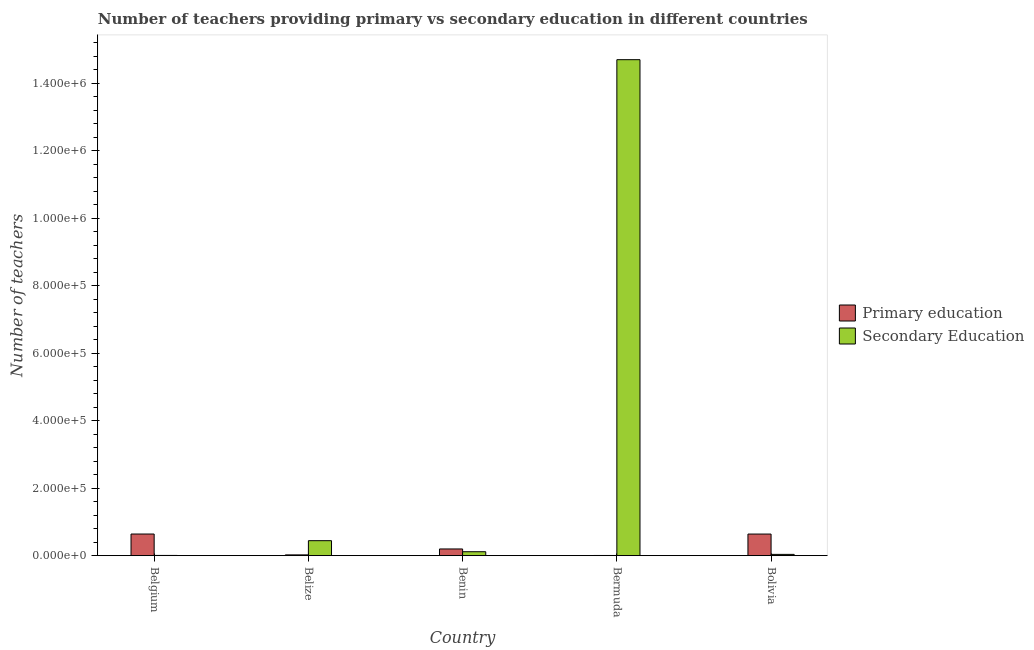How many different coloured bars are there?
Your response must be concise. 2. Are the number of bars per tick equal to the number of legend labels?
Ensure brevity in your answer.  Yes. Are the number of bars on each tick of the X-axis equal?
Give a very brief answer. Yes. How many bars are there on the 1st tick from the left?
Give a very brief answer. 2. How many bars are there on the 3rd tick from the right?
Provide a succinct answer. 2. What is the number of secondary teachers in Bermuda?
Your answer should be very brief. 1.47e+06. Across all countries, what is the maximum number of primary teachers?
Provide a succinct answer. 6.41e+04. Across all countries, what is the minimum number of secondary teachers?
Your response must be concise. 687. In which country was the number of secondary teachers maximum?
Offer a terse response. Bermuda. What is the total number of primary teachers in the graph?
Make the answer very short. 1.51e+05. What is the difference between the number of primary teachers in Benin and that in Bolivia?
Provide a succinct answer. -4.42e+04. What is the difference between the number of secondary teachers in Bermuda and the number of primary teachers in Bolivia?
Ensure brevity in your answer.  1.41e+06. What is the average number of secondary teachers per country?
Your response must be concise. 3.06e+05. What is the difference between the number of primary teachers and number of secondary teachers in Bolivia?
Your response must be concise. 6.03e+04. In how many countries, is the number of primary teachers greater than 440000 ?
Make the answer very short. 0. What is the ratio of the number of secondary teachers in Belgium to that in Bermuda?
Your answer should be compact. 0. Is the difference between the number of primary teachers in Belgium and Benin greater than the difference between the number of secondary teachers in Belgium and Benin?
Your response must be concise. Yes. What is the difference between the highest and the second highest number of secondary teachers?
Your answer should be compact. 1.43e+06. What is the difference between the highest and the lowest number of secondary teachers?
Your answer should be compact. 1.47e+06. Is the sum of the number of primary teachers in Belize and Bolivia greater than the maximum number of secondary teachers across all countries?
Provide a succinct answer. No. What does the 2nd bar from the right in Bermuda represents?
Ensure brevity in your answer.  Primary education. How many bars are there?
Offer a terse response. 10. Does the graph contain any zero values?
Your answer should be very brief. No. How many legend labels are there?
Provide a short and direct response. 2. What is the title of the graph?
Give a very brief answer. Number of teachers providing primary vs secondary education in different countries. Does "IMF concessional" appear as one of the legend labels in the graph?
Make the answer very short. No. What is the label or title of the X-axis?
Give a very brief answer. Country. What is the label or title of the Y-axis?
Provide a short and direct response. Number of teachers. What is the Number of teachers in Primary education in Belgium?
Provide a succinct answer. 6.41e+04. What is the Number of teachers of Secondary Education in Belgium?
Provide a succinct answer. 687. What is the Number of teachers in Primary education in Belize?
Provide a succinct answer. 2274. What is the Number of teachers in Secondary Education in Belize?
Keep it short and to the point. 4.44e+04. What is the Number of teachers in Primary education in Benin?
Give a very brief answer. 1.98e+04. What is the Number of teachers of Secondary Education in Benin?
Offer a terse response. 1.16e+04. What is the Number of teachers of Primary education in Bermuda?
Your response must be concise. 548. What is the Number of teachers in Secondary Education in Bermuda?
Offer a terse response. 1.47e+06. What is the Number of teachers in Primary education in Bolivia?
Provide a short and direct response. 6.40e+04. What is the Number of teachers of Secondary Education in Bolivia?
Your response must be concise. 3765. Across all countries, what is the maximum Number of teachers in Primary education?
Your response must be concise. 6.41e+04. Across all countries, what is the maximum Number of teachers of Secondary Education?
Give a very brief answer. 1.47e+06. Across all countries, what is the minimum Number of teachers of Primary education?
Your answer should be compact. 548. Across all countries, what is the minimum Number of teachers of Secondary Education?
Give a very brief answer. 687. What is the total Number of teachers of Primary education in the graph?
Keep it short and to the point. 1.51e+05. What is the total Number of teachers in Secondary Education in the graph?
Your answer should be compact. 1.53e+06. What is the difference between the Number of teachers of Primary education in Belgium and that in Belize?
Your answer should be compact. 6.19e+04. What is the difference between the Number of teachers of Secondary Education in Belgium and that in Belize?
Keep it short and to the point. -4.37e+04. What is the difference between the Number of teachers of Primary education in Belgium and that in Benin?
Your response must be concise. 4.43e+04. What is the difference between the Number of teachers in Secondary Education in Belgium and that in Benin?
Your answer should be very brief. -1.10e+04. What is the difference between the Number of teachers in Primary education in Belgium and that in Bermuda?
Give a very brief answer. 6.36e+04. What is the difference between the Number of teachers of Secondary Education in Belgium and that in Bermuda?
Provide a short and direct response. -1.47e+06. What is the difference between the Number of teachers of Secondary Education in Belgium and that in Bolivia?
Offer a very short reply. -3078. What is the difference between the Number of teachers of Primary education in Belize and that in Benin?
Provide a succinct answer. -1.76e+04. What is the difference between the Number of teachers of Secondary Education in Belize and that in Benin?
Offer a terse response. 3.27e+04. What is the difference between the Number of teachers of Primary education in Belize and that in Bermuda?
Keep it short and to the point. 1726. What is the difference between the Number of teachers in Secondary Education in Belize and that in Bermuda?
Provide a succinct answer. -1.43e+06. What is the difference between the Number of teachers in Primary education in Belize and that in Bolivia?
Make the answer very short. -6.18e+04. What is the difference between the Number of teachers in Secondary Education in Belize and that in Bolivia?
Keep it short and to the point. 4.06e+04. What is the difference between the Number of teachers in Primary education in Benin and that in Bermuda?
Your answer should be compact. 1.93e+04. What is the difference between the Number of teachers in Secondary Education in Benin and that in Bermuda?
Provide a succinct answer. -1.46e+06. What is the difference between the Number of teachers in Primary education in Benin and that in Bolivia?
Offer a very short reply. -4.42e+04. What is the difference between the Number of teachers in Secondary Education in Benin and that in Bolivia?
Keep it short and to the point. 7875. What is the difference between the Number of teachers of Primary education in Bermuda and that in Bolivia?
Give a very brief answer. -6.35e+04. What is the difference between the Number of teachers in Secondary Education in Bermuda and that in Bolivia?
Provide a succinct answer. 1.47e+06. What is the difference between the Number of teachers of Primary education in Belgium and the Number of teachers of Secondary Education in Belize?
Ensure brevity in your answer.  1.98e+04. What is the difference between the Number of teachers of Primary education in Belgium and the Number of teachers of Secondary Education in Benin?
Give a very brief answer. 5.25e+04. What is the difference between the Number of teachers in Primary education in Belgium and the Number of teachers in Secondary Education in Bermuda?
Make the answer very short. -1.41e+06. What is the difference between the Number of teachers of Primary education in Belgium and the Number of teachers of Secondary Education in Bolivia?
Your answer should be very brief. 6.04e+04. What is the difference between the Number of teachers of Primary education in Belize and the Number of teachers of Secondary Education in Benin?
Your response must be concise. -9366. What is the difference between the Number of teachers of Primary education in Belize and the Number of teachers of Secondary Education in Bermuda?
Offer a very short reply. -1.47e+06. What is the difference between the Number of teachers of Primary education in Belize and the Number of teachers of Secondary Education in Bolivia?
Provide a succinct answer. -1491. What is the difference between the Number of teachers in Primary education in Benin and the Number of teachers in Secondary Education in Bermuda?
Offer a very short reply. -1.45e+06. What is the difference between the Number of teachers of Primary education in Benin and the Number of teachers of Secondary Education in Bolivia?
Provide a succinct answer. 1.61e+04. What is the difference between the Number of teachers in Primary education in Bermuda and the Number of teachers in Secondary Education in Bolivia?
Offer a terse response. -3217. What is the average Number of teachers in Primary education per country?
Ensure brevity in your answer.  3.02e+04. What is the average Number of teachers of Secondary Education per country?
Give a very brief answer. 3.06e+05. What is the difference between the Number of teachers in Primary education and Number of teachers in Secondary Education in Belgium?
Make the answer very short. 6.34e+04. What is the difference between the Number of teachers of Primary education and Number of teachers of Secondary Education in Belize?
Provide a succinct answer. -4.21e+04. What is the difference between the Number of teachers in Primary education and Number of teachers in Secondary Education in Benin?
Offer a very short reply. 8196. What is the difference between the Number of teachers in Primary education and Number of teachers in Secondary Education in Bermuda?
Provide a short and direct response. -1.47e+06. What is the difference between the Number of teachers in Primary education and Number of teachers in Secondary Education in Bolivia?
Provide a succinct answer. 6.03e+04. What is the ratio of the Number of teachers of Primary education in Belgium to that in Belize?
Your response must be concise. 28.2. What is the ratio of the Number of teachers of Secondary Education in Belgium to that in Belize?
Keep it short and to the point. 0.02. What is the ratio of the Number of teachers in Primary education in Belgium to that in Benin?
Keep it short and to the point. 3.23. What is the ratio of the Number of teachers in Secondary Education in Belgium to that in Benin?
Give a very brief answer. 0.06. What is the ratio of the Number of teachers in Primary education in Belgium to that in Bermuda?
Give a very brief answer. 117.02. What is the ratio of the Number of teachers in Secondary Education in Belgium to that in Bermuda?
Offer a terse response. 0. What is the ratio of the Number of teachers in Primary education in Belgium to that in Bolivia?
Provide a succinct answer. 1. What is the ratio of the Number of teachers in Secondary Education in Belgium to that in Bolivia?
Your response must be concise. 0.18. What is the ratio of the Number of teachers of Primary education in Belize to that in Benin?
Your answer should be compact. 0.11. What is the ratio of the Number of teachers in Secondary Education in Belize to that in Benin?
Offer a very short reply. 3.81. What is the ratio of the Number of teachers of Primary education in Belize to that in Bermuda?
Keep it short and to the point. 4.15. What is the ratio of the Number of teachers of Secondary Education in Belize to that in Bermuda?
Your answer should be very brief. 0.03. What is the ratio of the Number of teachers of Primary education in Belize to that in Bolivia?
Offer a very short reply. 0.04. What is the ratio of the Number of teachers in Secondary Education in Belize to that in Bolivia?
Give a very brief answer. 11.78. What is the ratio of the Number of teachers in Primary education in Benin to that in Bermuda?
Ensure brevity in your answer.  36.2. What is the ratio of the Number of teachers in Secondary Education in Benin to that in Bermuda?
Offer a very short reply. 0.01. What is the ratio of the Number of teachers of Primary education in Benin to that in Bolivia?
Provide a succinct answer. 0.31. What is the ratio of the Number of teachers in Secondary Education in Benin to that in Bolivia?
Make the answer very short. 3.09. What is the ratio of the Number of teachers in Primary education in Bermuda to that in Bolivia?
Your answer should be very brief. 0.01. What is the ratio of the Number of teachers of Secondary Education in Bermuda to that in Bolivia?
Ensure brevity in your answer.  390.43. What is the difference between the highest and the second highest Number of teachers of Secondary Education?
Make the answer very short. 1.43e+06. What is the difference between the highest and the lowest Number of teachers in Primary education?
Ensure brevity in your answer.  6.36e+04. What is the difference between the highest and the lowest Number of teachers in Secondary Education?
Keep it short and to the point. 1.47e+06. 